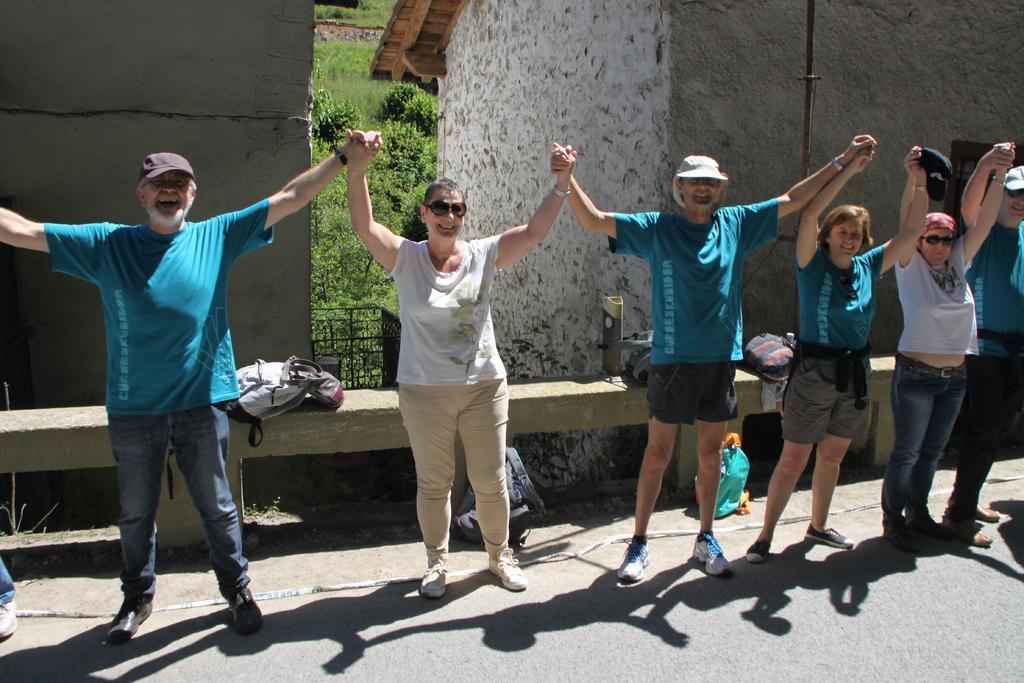Describe this image in one or two sentences. In the center of the image there are group of persons standing on the road. In the background there are buildings, trees and grass. 